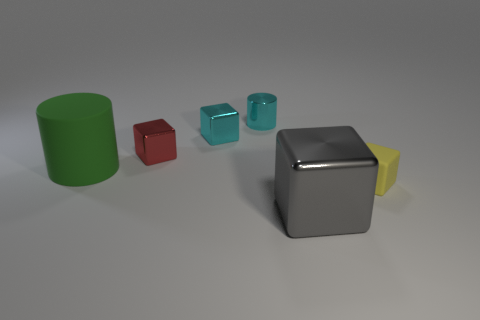Subtract all gray blocks. How many blocks are left? 3 Subtract all brown cubes. Subtract all brown cylinders. How many cubes are left? 4 Add 2 small cyan things. How many objects exist? 8 Subtract all blocks. How many objects are left? 2 Subtract all large cyan shiny cylinders. Subtract all shiny blocks. How many objects are left? 3 Add 1 tiny red blocks. How many tiny red blocks are left? 2 Add 5 big cyan rubber things. How many big cyan rubber things exist? 5 Subtract 0 green blocks. How many objects are left? 6 